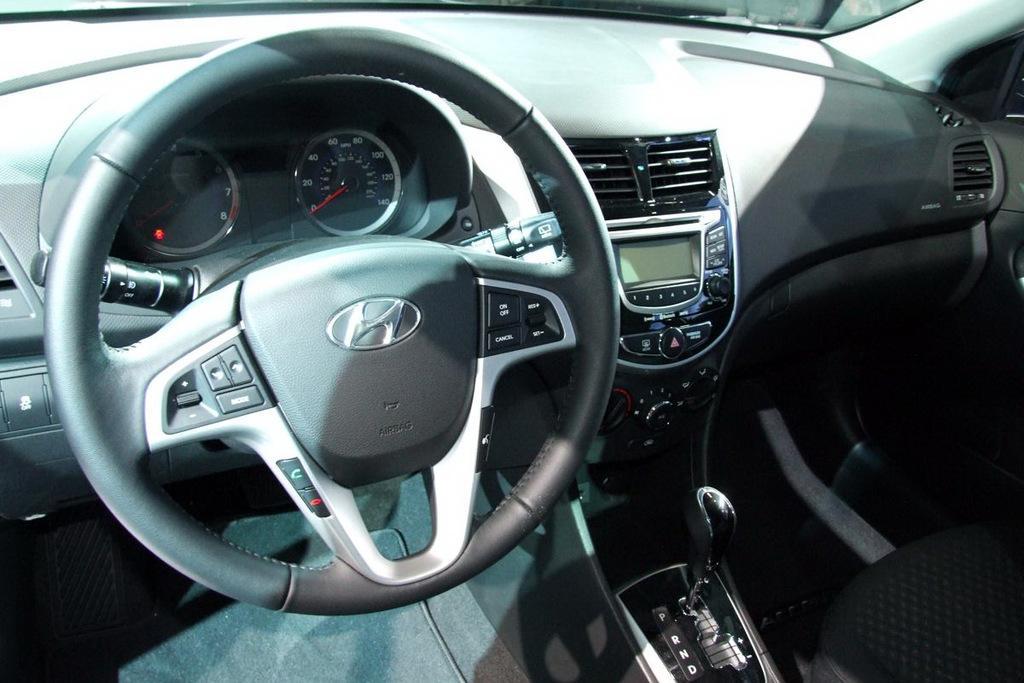Describe this image in one or two sentences. This is a picture of inside of a vehicle, in this image in the center there is a steering, speed meters, seat, gear and some objects. 